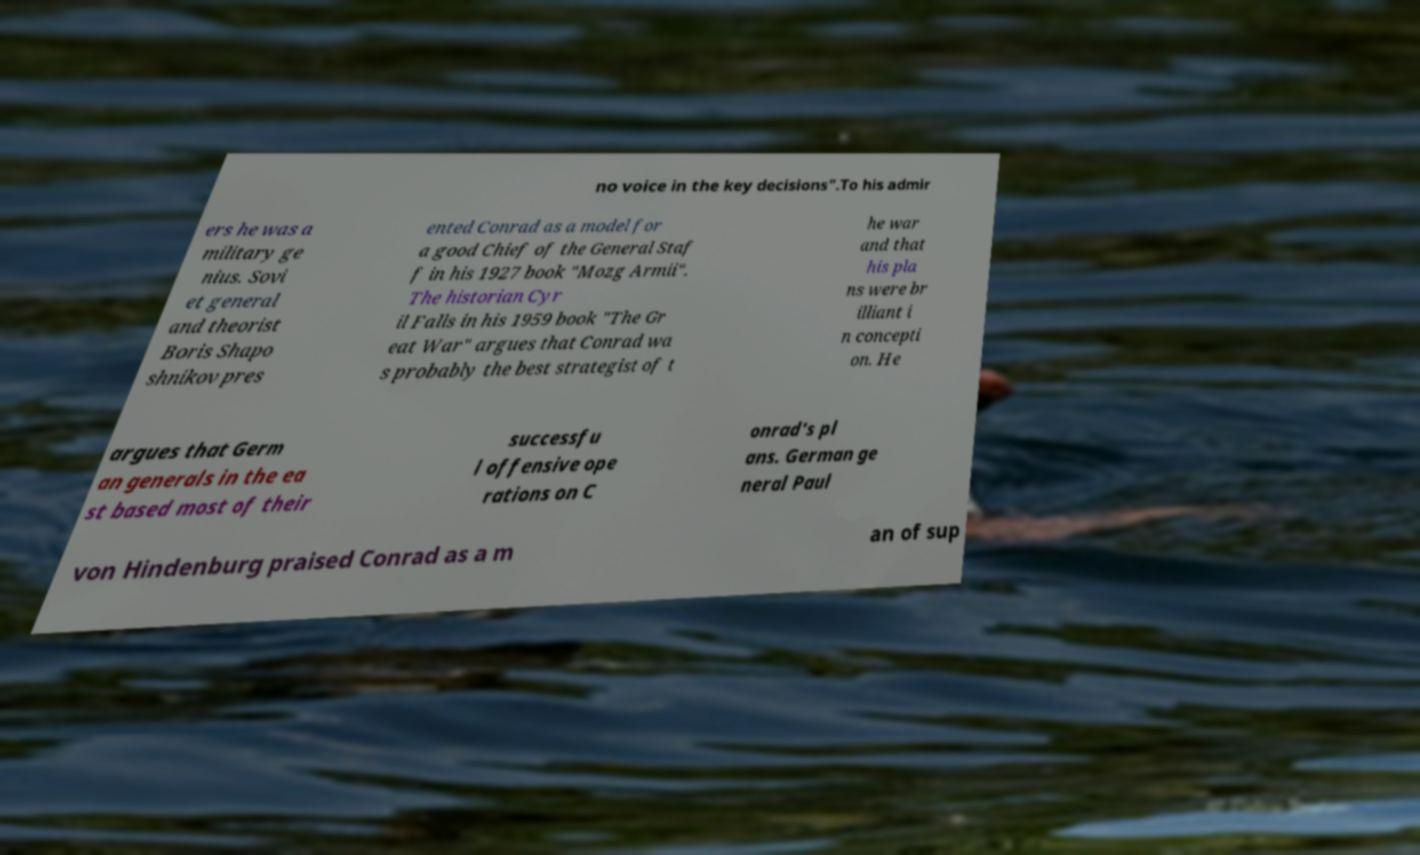Could you extract and type out the text from this image? no voice in the key decisions".To his admir ers he was a military ge nius. Sovi et general and theorist Boris Shapo shnikov pres ented Conrad as a model for a good Chief of the General Staf f in his 1927 book "Mozg Armii". The historian Cyr il Falls in his 1959 book "The Gr eat War" argues that Conrad wa s probably the best strategist of t he war and that his pla ns were br illiant i n concepti on. He argues that Germ an generals in the ea st based most of their successfu l offensive ope rations on C onrad's pl ans. German ge neral Paul von Hindenburg praised Conrad as a m an of sup 